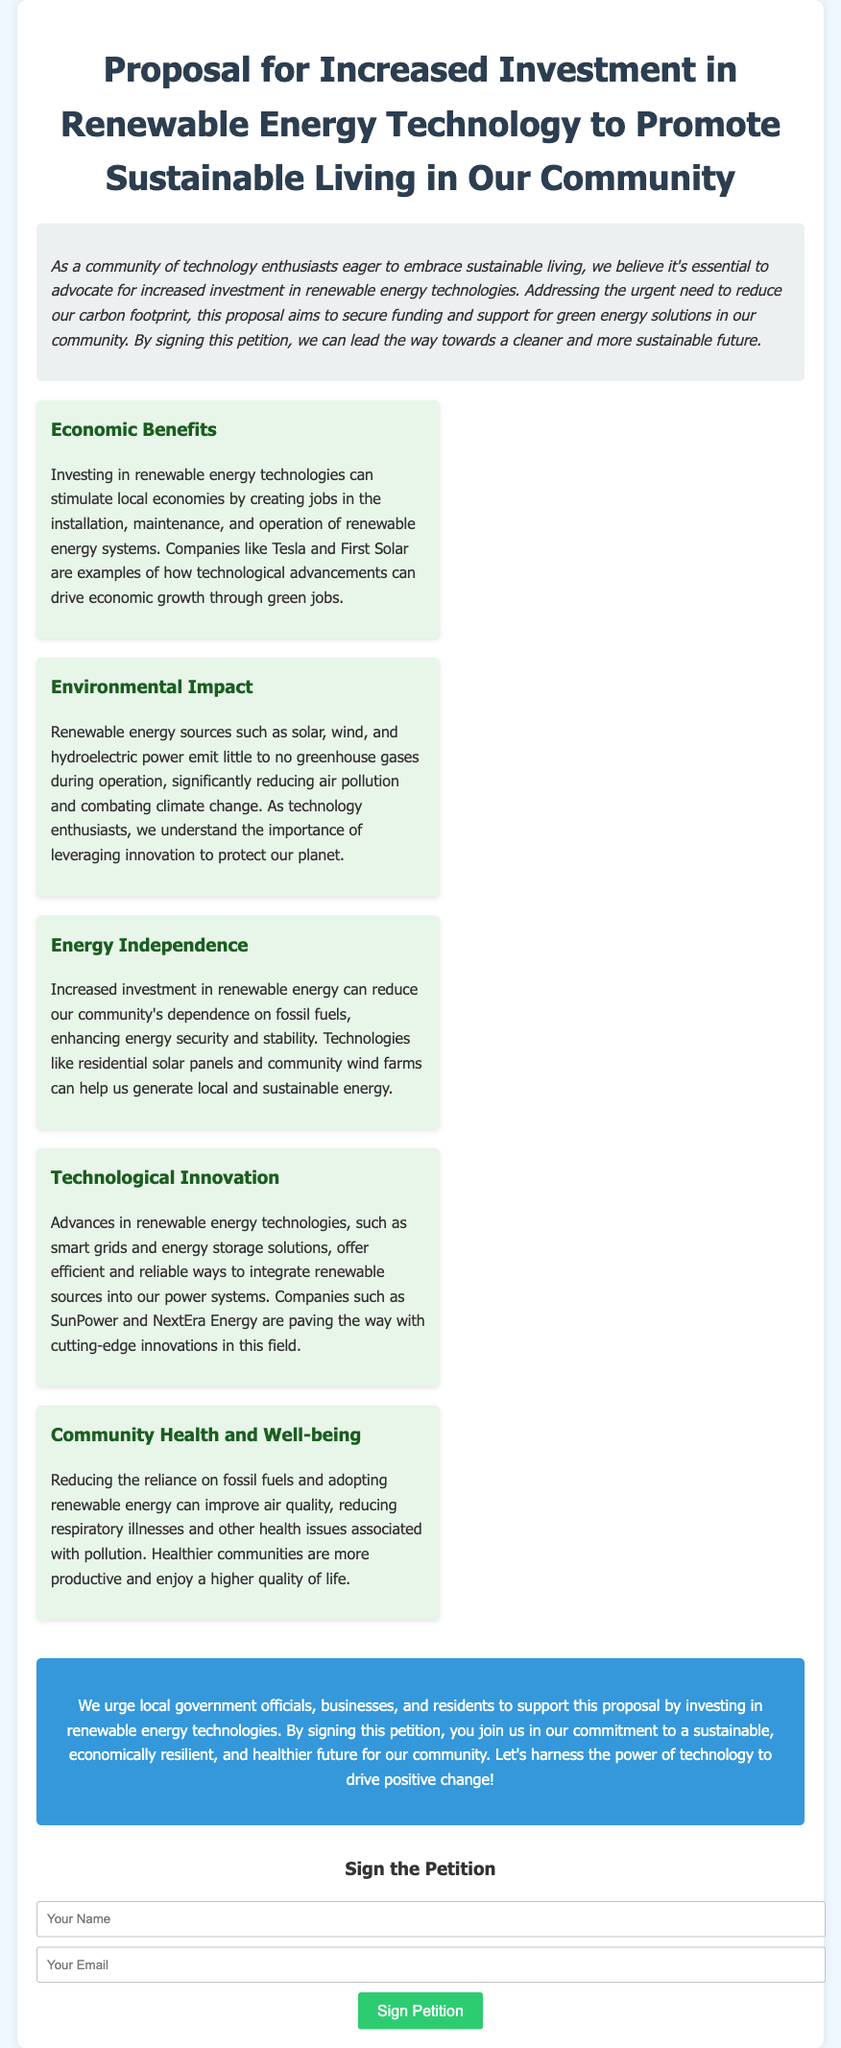What is the title of the petition? The title is presented in the header of the document and identifies the main focus of the petition.
Answer: Proposal for Increased Investment in Renewable Energy Technology to Promote Sustainable Living in Our Community What are the key areas mentioned for investment? The key areas are highlighted in separate sections throughout the document, focusing on different aspects of renewable energy investment.
Answer: Economic Benefits, Environmental Impact, Energy Independence, Technological Innovation, Community Health and Well-being Who are the companies mentioned as examples in the document? The document cites specific companies to illustrate points made in the proposal.
Answer: Tesla, First Solar, SunPower, NextEra Energy What is the main call to action in the petition? The call to action outlines what the petitioners want from the local government officials, businesses, and residents.
Answer: Support this proposal by investing in renewable energy technologies What benefit does renewable energy bring to community health? The document describes the impact of renewable energy on health and well-being.
Answer: Improved air quality What is one technological advancement mentioned in the petition? The document provides examples of advancements in the field of renewable energy technology.
Answer: Smart grids How can individuals express their support for the petition? The document outlines how supporters can officially add their signatures to the petition.
Answer: By signing the petition What type of energy sources are highlighted as renewable in the document? The document explicitly names sources that qualify as renewable energy.
Answer: Solar, wind, hydroelectric Which section emphasizes the economic impacts of renewable energy investment? The document organizes information into sections, one of which examines the economic effects.
Answer: Economic Benefits 